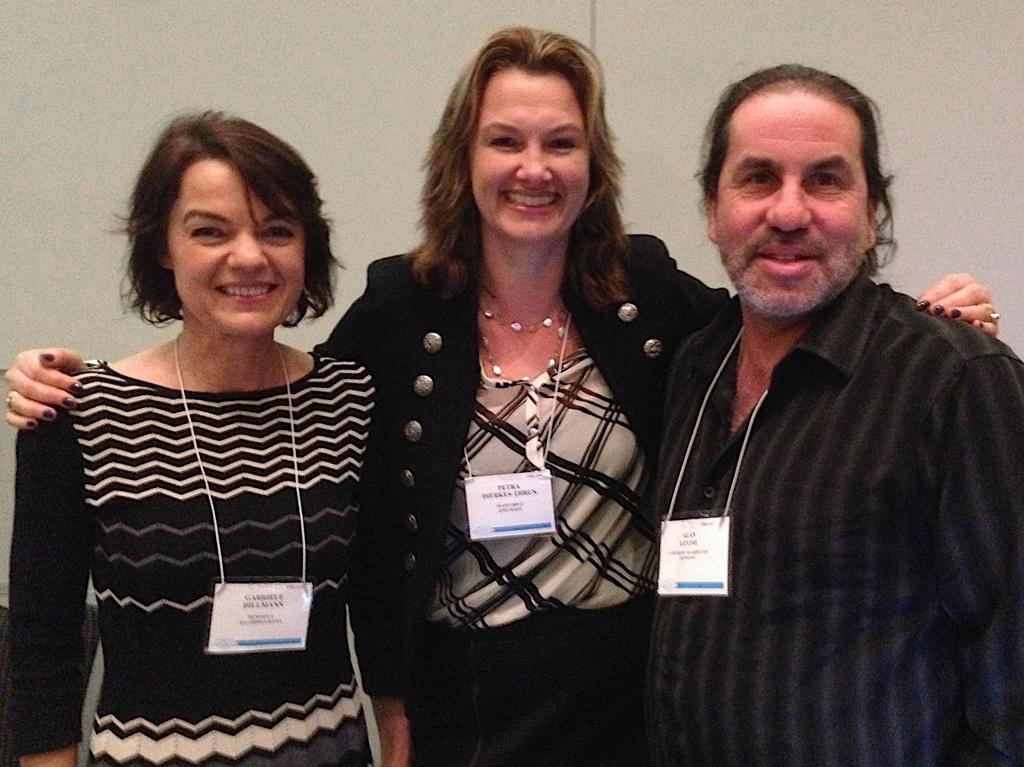Describe this image in one or two sentences. In this image there are three persons are standing and smiling as we can see in middle of this image and there is a wall in the background and these three persons are wearing id cards which is in white color. 